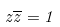<formula> <loc_0><loc_0><loc_500><loc_500>z \overline { z } = 1</formula> 